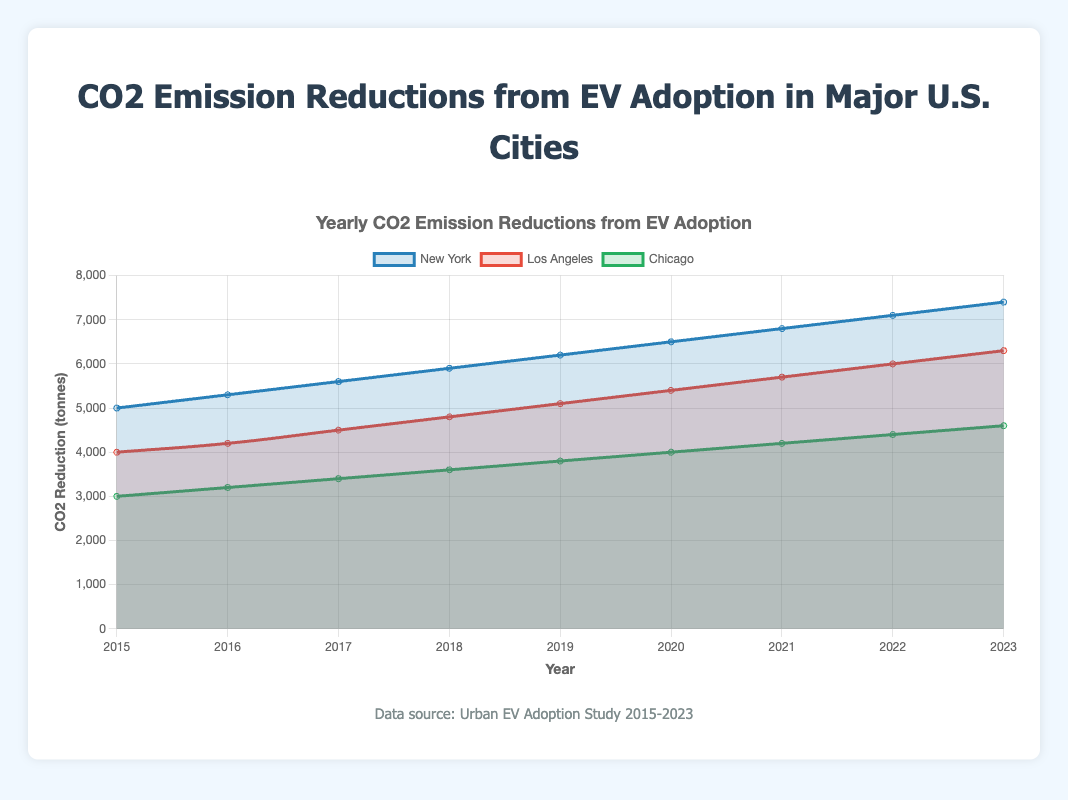How did the CO2 emission reductions change from 2015 to 2023 for New York? First, look at the values for New York for 2015 and 2023 on the chart. The reduction in 2015 is 5000 tonnes, and in 2023 it is 7400 tonnes, so the change is 7400 - 5000 = 2400 tonnes.
Answer: 2400 tonnes Which city had the highest CO2 reduction in 2023? Look at the endpoints of the lines for 2023 and compare the values. New York's line ends at the highest value of 7400 tonnes.
Answer: New York On average, what were the yearly CO2 emission reductions in Chicago between 2015 and 2023? Sum up the values for Chicago for each year and divide by the number of years (4600 + 4400 + 4200 + 4000 + 3800 + 3600 + 3400 + 3200 + 3000) / 9 = 3644.4 tonnes.
Answer: 3644.4 tonnes By how much did Los Angeles' CO2 reduction increase between 2018 and 2023? Find the values for Los Angeles in 2018 and 2023 from the line chart. The reduction is 4800 tonnes in 2018 and 6300 tonnes in 2023. So, the increase is 6300 - 4800 = 1500 tonnes.
Answer: 1500 tonnes How does the 2020 CO2 emission reduction in New York compare to Los Angeles' CO2 reduction in the same year? From the chart, New York's value for 2020 is 6500 tonnes, and Los Angeles' value is 5400 tonnes. Compare these values: 6500 is greater than 5400.
Answer: New York had greater reduction Which city saw the most consistent yearly increase in CO2 emission reductions from 2015 to 2023? Observe the slope and steady increase in the lines over the years. New York shows a consistent yearly increase without large variations.
Answer: New York If the trend continues, what could be the possible CO2 reduction for Los Angeles in 2024? Identify the yearly increase from previous values. Los Angeles increases nearly 300 tonnes per year. Extrapolating to 2024: 6300 + 300 = 6600 tonnes.
Answer: 6600 tonnes Which city had the smallest total increase in CO2 reduction from 2015 to 2023? Calculate the difference between 2023 and 2015 for each city: New York (7400 - 5000 = 2400), Los Angeles (6300 - 4000 = 2300), Chicago (4600 - 3000 = 1600). Chicago has the smallest increase.
Answer: Chicago What color represents the data for Chicago in the chart? Look at the explanation of the color coding in the legend or directly from the lines. Chicago is represented by green.
Answer: Green 